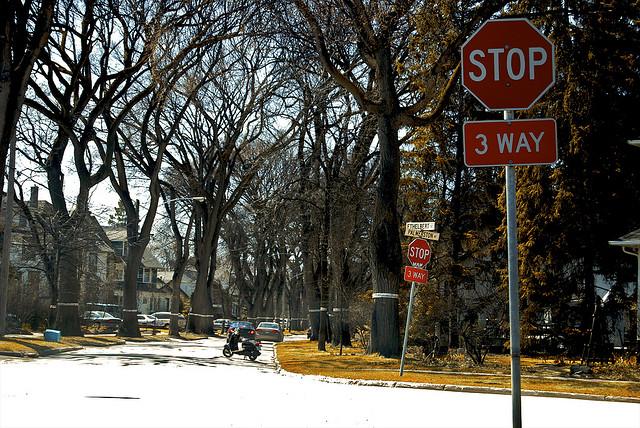Is it a 4 Way Stop sign?
Write a very short answer. No. Is this a game?
Give a very brief answer. No. How many stop signs are in the picture?
Quick response, please. 2. What direction is this photo taken?
Write a very short answer. East. 